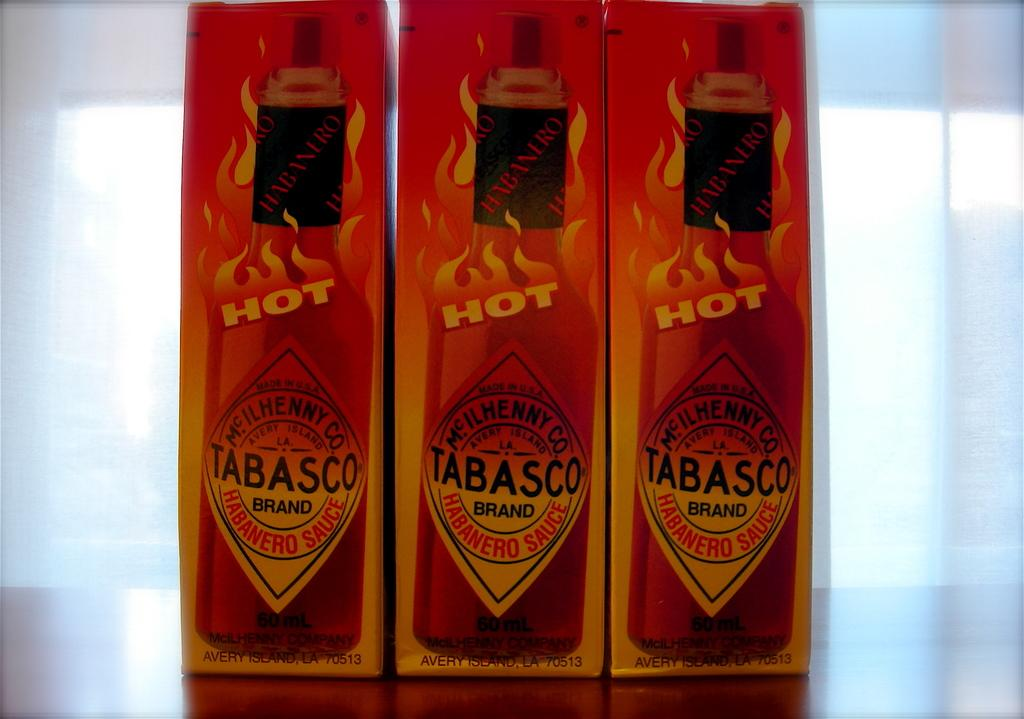What objects are on the table in the foreground of the image? There are three packets on a table in the foreground of the image. Can you describe the background of the image? The background of the image is blurred. What is the purpose of the zinc in the image? There is no zinc present in the image, so it cannot serve any purpose in the context of the image. 